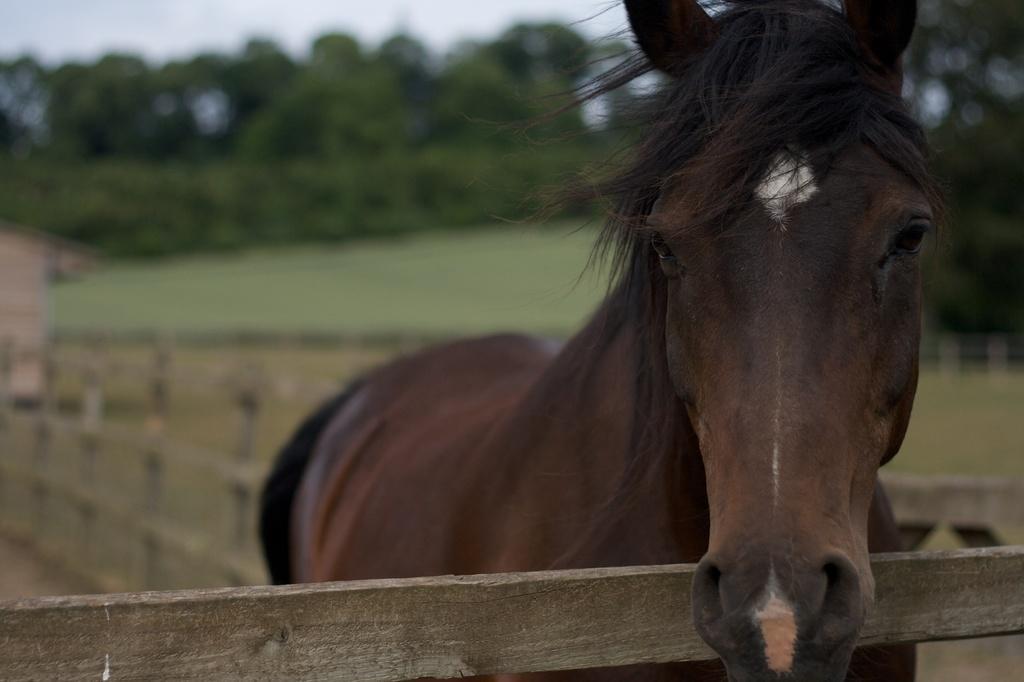Please provide a concise description of this image. In this image there is the sky towards the top of the image, there are trees, there is grass, there is an object towards the left of the image, there is a wooden fence, there is a horse. 